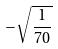<formula> <loc_0><loc_0><loc_500><loc_500>- \sqrt { \frac { 1 } { 7 0 } }</formula> 